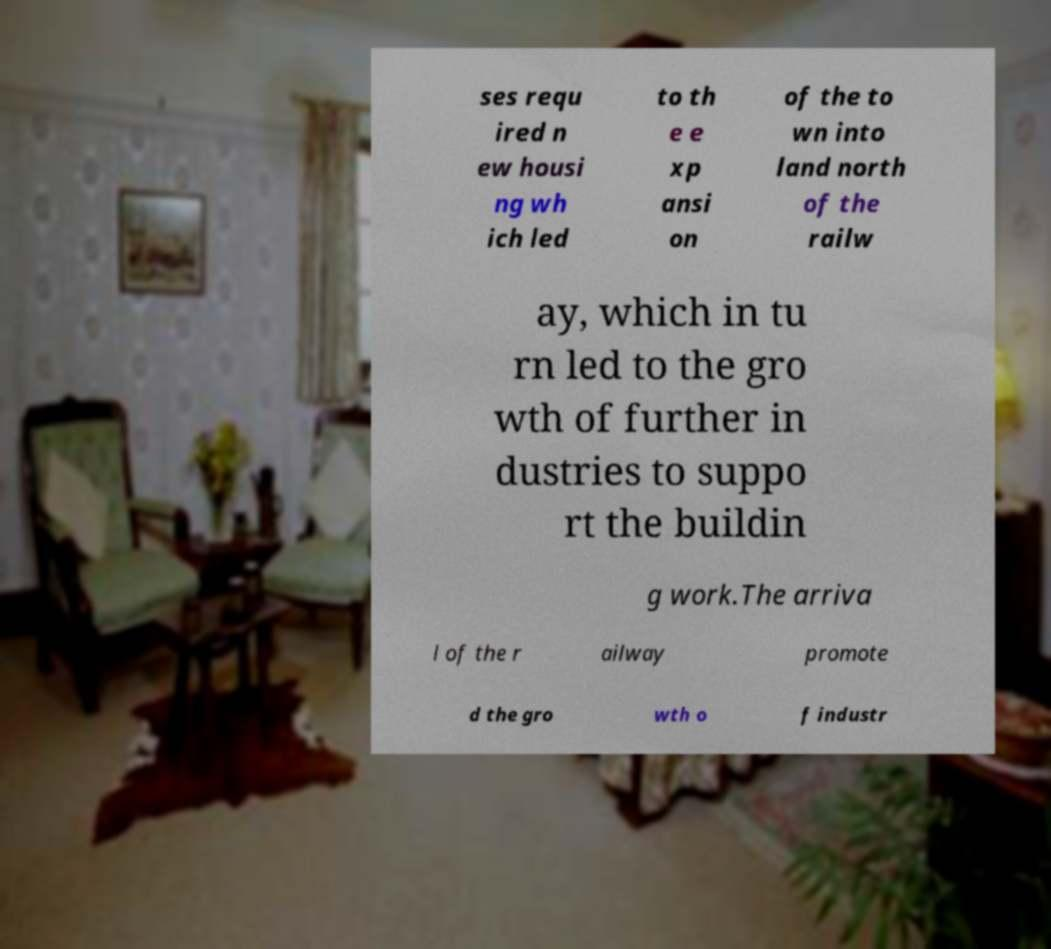Please read and relay the text visible in this image. What does it say? ses requ ired n ew housi ng wh ich led to th e e xp ansi on of the to wn into land north of the railw ay, which in tu rn led to the gro wth of further in dustries to suppo rt the buildin g work.The arriva l of the r ailway promote d the gro wth o f industr 